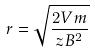Convert formula to latex. <formula><loc_0><loc_0><loc_500><loc_500>r = \sqrt { \frac { 2 V m } { z B ^ { 2 } } }</formula> 